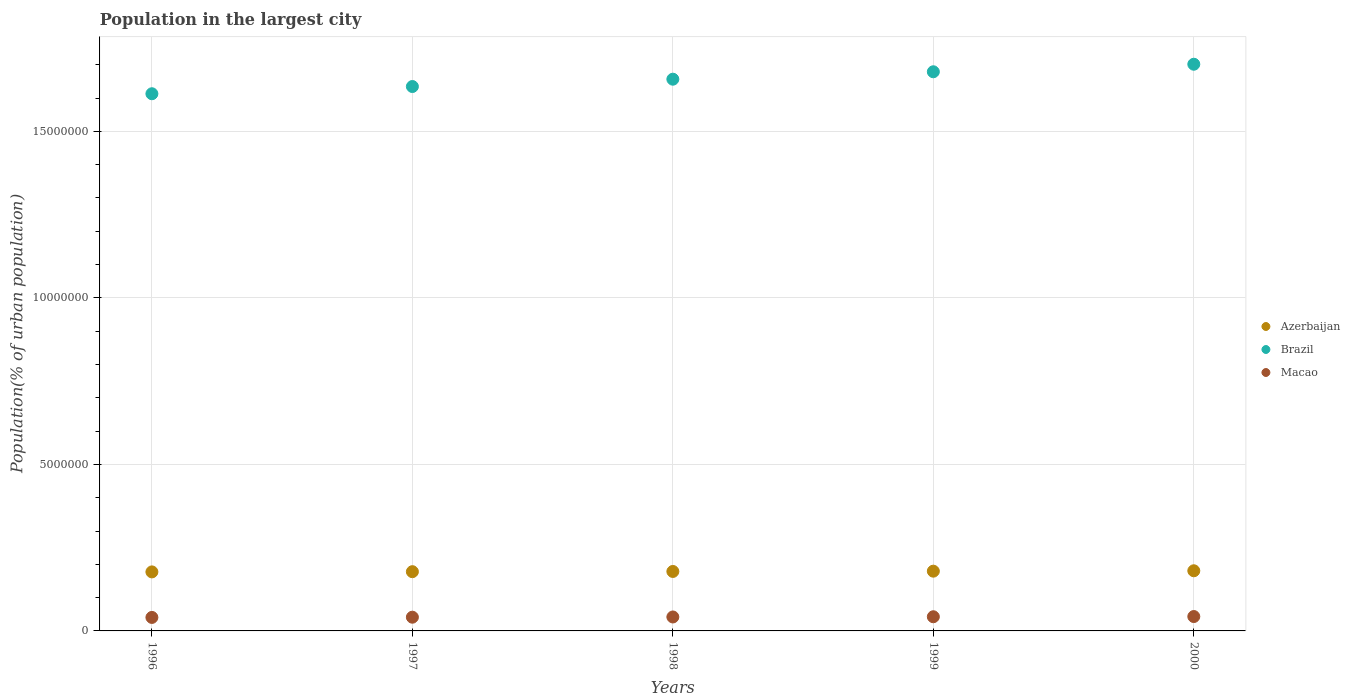How many different coloured dotlines are there?
Offer a terse response. 3. Is the number of dotlines equal to the number of legend labels?
Provide a succinct answer. Yes. What is the population in the largest city in Brazil in 1997?
Offer a very short reply. 1.63e+07. Across all years, what is the maximum population in the largest city in Brazil?
Give a very brief answer. 1.70e+07. Across all years, what is the minimum population in the largest city in Macao?
Your answer should be compact. 4.05e+05. What is the total population in the largest city in Brazil in the graph?
Ensure brevity in your answer.  8.28e+07. What is the difference between the population in the largest city in Macao in 1996 and that in 1999?
Give a very brief answer. -2.03e+04. What is the difference between the population in the largest city in Macao in 1997 and the population in the largest city in Brazil in 2000?
Make the answer very short. -1.66e+07. What is the average population in the largest city in Azerbaijan per year?
Make the answer very short. 1.79e+06. In the year 1996, what is the difference between the population in the largest city in Macao and population in the largest city in Azerbaijan?
Make the answer very short. -1.37e+06. What is the ratio of the population in the largest city in Brazil in 1998 to that in 2000?
Ensure brevity in your answer.  0.97. Is the population in the largest city in Macao in 1998 less than that in 2000?
Ensure brevity in your answer.  Yes. What is the difference between the highest and the second highest population in the largest city in Azerbaijan?
Provide a succinct answer. 1.20e+04. What is the difference between the highest and the lowest population in the largest city in Azerbaijan?
Make the answer very short. 3.39e+04. In how many years, is the population in the largest city in Macao greater than the average population in the largest city in Macao taken over all years?
Offer a terse response. 3. Is the sum of the population in the largest city in Azerbaijan in 1998 and 2000 greater than the maximum population in the largest city in Brazil across all years?
Offer a terse response. No. Does the population in the largest city in Macao monotonically increase over the years?
Your answer should be very brief. Yes. Is the population in the largest city in Azerbaijan strictly greater than the population in the largest city in Macao over the years?
Give a very brief answer. Yes. How many years are there in the graph?
Ensure brevity in your answer.  5. Are the values on the major ticks of Y-axis written in scientific E-notation?
Ensure brevity in your answer.  No. Where does the legend appear in the graph?
Ensure brevity in your answer.  Center right. What is the title of the graph?
Give a very brief answer. Population in the largest city. Does "Brazil" appear as one of the legend labels in the graph?
Offer a very short reply. Yes. What is the label or title of the X-axis?
Provide a short and direct response. Years. What is the label or title of the Y-axis?
Keep it short and to the point. Population(% of urban population). What is the Population(% of urban population) of Azerbaijan in 1996?
Ensure brevity in your answer.  1.77e+06. What is the Population(% of urban population) in Brazil in 1996?
Make the answer very short. 1.61e+07. What is the Population(% of urban population) in Macao in 1996?
Ensure brevity in your answer.  4.05e+05. What is the Population(% of urban population) of Azerbaijan in 1997?
Provide a short and direct response. 1.78e+06. What is the Population(% of urban population) of Brazil in 1997?
Provide a short and direct response. 1.63e+07. What is the Population(% of urban population) in Macao in 1997?
Provide a short and direct response. 4.12e+05. What is the Population(% of urban population) in Azerbaijan in 1998?
Offer a terse response. 1.79e+06. What is the Population(% of urban population) of Brazil in 1998?
Keep it short and to the point. 1.66e+07. What is the Population(% of urban population) of Macao in 1998?
Offer a terse response. 4.19e+05. What is the Population(% of urban population) in Azerbaijan in 1999?
Provide a short and direct response. 1.79e+06. What is the Population(% of urban population) of Brazil in 1999?
Provide a succinct answer. 1.68e+07. What is the Population(% of urban population) of Macao in 1999?
Your answer should be compact. 4.25e+05. What is the Population(% of urban population) in Azerbaijan in 2000?
Offer a very short reply. 1.81e+06. What is the Population(% of urban population) of Brazil in 2000?
Provide a short and direct response. 1.70e+07. What is the Population(% of urban population) in Macao in 2000?
Offer a very short reply. 4.32e+05. Across all years, what is the maximum Population(% of urban population) in Azerbaijan?
Your answer should be compact. 1.81e+06. Across all years, what is the maximum Population(% of urban population) in Brazil?
Your answer should be very brief. 1.70e+07. Across all years, what is the maximum Population(% of urban population) in Macao?
Make the answer very short. 4.32e+05. Across all years, what is the minimum Population(% of urban population) in Azerbaijan?
Offer a very short reply. 1.77e+06. Across all years, what is the minimum Population(% of urban population) in Brazil?
Ensure brevity in your answer.  1.61e+07. Across all years, what is the minimum Population(% of urban population) in Macao?
Make the answer very short. 4.05e+05. What is the total Population(% of urban population) in Azerbaijan in the graph?
Offer a very short reply. 8.94e+06. What is the total Population(% of urban population) in Brazil in the graph?
Provide a succinct answer. 8.28e+07. What is the total Population(% of urban population) of Macao in the graph?
Ensure brevity in your answer.  2.09e+06. What is the difference between the Population(% of urban population) in Azerbaijan in 1996 and that in 1997?
Your answer should be very brief. -6504. What is the difference between the Population(% of urban population) in Brazil in 1996 and that in 1997?
Make the answer very short. -2.17e+05. What is the difference between the Population(% of urban population) of Macao in 1996 and that in 1997?
Give a very brief answer. -6883. What is the difference between the Population(% of urban population) in Azerbaijan in 1996 and that in 1998?
Give a very brief answer. -1.30e+04. What is the difference between the Population(% of urban population) in Brazil in 1996 and that in 1998?
Ensure brevity in your answer.  -4.37e+05. What is the difference between the Population(% of urban population) of Macao in 1996 and that in 1998?
Provide a succinct answer. -1.37e+04. What is the difference between the Population(% of urban population) in Azerbaijan in 1996 and that in 1999?
Your response must be concise. -2.19e+04. What is the difference between the Population(% of urban population) in Brazil in 1996 and that in 1999?
Offer a terse response. -6.60e+05. What is the difference between the Population(% of urban population) in Macao in 1996 and that in 1999?
Offer a terse response. -2.03e+04. What is the difference between the Population(% of urban population) in Azerbaijan in 1996 and that in 2000?
Provide a succinct answer. -3.39e+04. What is the difference between the Population(% of urban population) in Brazil in 1996 and that in 2000?
Your answer should be compact. -8.86e+05. What is the difference between the Population(% of urban population) in Macao in 1996 and that in 2000?
Give a very brief answer. -2.68e+04. What is the difference between the Population(% of urban population) in Azerbaijan in 1997 and that in 1998?
Offer a terse response. -6537. What is the difference between the Population(% of urban population) in Brazil in 1997 and that in 1998?
Provide a succinct answer. -2.20e+05. What is the difference between the Population(% of urban population) in Macao in 1997 and that in 1998?
Give a very brief answer. -6779. What is the difference between the Population(% of urban population) of Azerbaijan in 1997 and that in 1999?
Keep it short and to the point. -1.54e+04. What is the difference between the Population(% of urban population) of Brazil in 1997 and that in 1999?
Your answer should be compact. -4.43e+05. What is the difference between the Population(% of urban population) of Macao in 1997 and that in 1999?
Your answer should be compact. -1.34e+04. What is the difference between the Population(% of urban population) of Azerbaijan in 1997 and that in 2000?
Your response must be concise. -2.74e+04. What is the difference between the Population(% of urban population) of Brazil in 1997 and that in 2000?
Provide a short and direct response. -6.69e+05. What is the difference between the Population(% of urban population) in Macao in 1997 and that in 2000?
Your response must be concise. -1.99e+04. What is the difference between the Population(% of urban population) of Azerbaijan in 1998 and that in 1999?
Offer a terse response. -8854. What is the difference between the Population(% of urban population) in Brazil in 1998 and that in 1999?
Offer a very short reply. -2.23e+05. What is the difference between the Population(% of urban population) in Macao in 1998 and that in 1999?
Provide a short and direct response. -6638. What is the difference between the Population(% of urban population) in Azerbaijan in 1998 and that in 2000?
Give a very brief answer. -2.09e+04. What is the difference between the Population(% of urban population) of Brazil in 1998 and that in 2000?
Give a very brief answer. -4.49e+05. What is the difference between the Population(% of urban population) in Macao in 1998 and that in 2000?
Ensure brevity in your answer.  -1.31e+04. What is the difference between the Population(% of urban population) of Azerbaijan in 1999 and that in 2000?
Ensure brevity in your answer.  -1.20e+04. What is the difference between the Population(% of urban population) in Brazil in 1999 and that in 2000?
Your answer should be very brief. -2.26e+05. What is the difference between the Population(% of urban population) of Macao in 1999 and that in 2000?
Give a very brief answer. -6459. What is the difference between the Population(% of urban population) of Azerbaijan in 1996 and the Population(% of urban population) of Brazil in 1997?
Provide a short and direct response. -1.46e+07. What is the difference between the Population(% of urban population) in Azerbaijan in 1996 and the Population(% of urban population) in Macao in 1997?
Give a very brief answer. 1.36e+06. What is the difference between the Population(% of urban population) of Brazil in 1996 and the Population(% of urban population) of Macao in 1997?
Ensure brevity in your answer.  1.57e+07. What is the difference between the Population(% of urban population) of Azerbaijan in 1996 and the Population(% of urban population) of Brazil in 1998?
Keep it short and to the point. -1.48e+07. What is the difference between the Population(% of urban population) in Azerbaijan in 1996 and the Population(% of urban population) in Macao in 1998?
Provide a succinct answer. 1.35e+06. What is the difference between the Population(% of urban population) in Brazil in 1996 and the Population(% of urban population) in Macao in 1998?
Make the answer very short. 1.57e+07. What is the difference between the Population(% of urban population) of Azerbaijan in 1996 and the Population(% of urban population) of Brazil in 1999?
Give a very brief answer. -1.50e+07. What is the difference between the Population(% of urban population) in Azerbaijan in 1996 and the Population(% of urban population) in Macao in 1999?
Offer a terse response. 1.35e+06. What is the difference between the Population(% of urban population) in Brazil in 1996 and the Population(% of urban population) in Macao in 1999?
Provide a succinct answer. 1.57e+07. What is the difference between the Population(% of urban population) in Azerbaijan in 1996 and the Population(% of urban population) in Brazil in 2000?
Keep it short and to the point. -1.52e+07. What is the difference between the Population(% of urban population) in Azerbaijan in 1996 and the Population(% of urban population) in Macao in 2000?
Ensure brevity in your answer.  1.34e+06. What is the difference between the Population(% of urban population) in Brazil in 1996 and the Population(% of urban population) in Macao in 2000?
Your answer should be compact. 1.57e+07. What is the difference between the Population(% of urban population) of Azerbaijan in 1997 and the Population(% of urban population) of Brazil in 1998?
Offer a very short reply. -1.48e+07. What is the difference between the Population(% of urban population) of Azerbaijan in 1997 and the Population(% of urban population) of Macao in 1998?
Your answer should be very brief. 1.36e+06. What is the difference between the Population(% of urban population) of Brazil in 1997 and the Population(% of urban population) of Macao in 1998?
Offer a very short reply. 1.59e+07. What is the difference between the Population(% of urban population) of Azerbaijan in 1997 and the Population(% of urban population) of Brazil in 1999?
Ensure brevity in your answer.  -1.50e+07. What is the difference between the Population(% of urban population) of Azerbaijan in 1997 and the Population(% of urban population) of Macao in 1999?
Provide a short and direct response. 1.35e+06. What is the difference between the Population(% of urban population) in Brazil in 1997 and the Population(% of urban population) in Macao in 1999?
Keep it short and to the point. 1.59e+07. What is the difference between the Population(% of urban population) in Azerbaijan in 1997 and the Population(% of urban population) in Brazil in 2000?
Make the answer very short. -1.52e+07. What is the difference between the Population(% of urban population) of Azerbaijan in 1997 and the Population(% of urban population) of Macao in 2000?
Provide a short and direct response. 1.35e+06. What is the difference between the Population(% of urban population) in Brazil in 1997 and the Population(% of urban population) in Macao in 2000?
Provide a short and direct response. 1.59e+07. What is the difference between the Population(% of urban population) of Azerbaijan in 1998 and the Population(% of urban population) of Brazil in 1999?
Provide a short and direct response. -1.50e+07. What is the difference between the Population(% of urban population) in Azerbaijan in 1998 and the Population(% of urban population) in Macao in 1999?
Offer a terse response. 1.36e+06. What is the difference between the Population(% of urban population) in Brazil in 1998 and the Population(% of urban population) in Macao in 1999?
Provide a succinct answer. 1.61e+07. What is the difference between the Population(% of urban population) of Azerbaijan in 1998 and the Population(% of urban population) of Brazil in 2000?
Provide a short and direct response. -1.52e+07. What is the difference between the Population(% of urban population) of Azerbaijan in 1998 and the Population(% of urban population) of Macao in 2000?
Give a very brief answer. 1.35e+06. What is the difference between the Population(% of urban population) in Brazil in 1998 and the Population(% of urban population) in Macao in 2000?
Give a very brief answer. 1.61e+07. What is the difference between the Population(% of urban population) in Azerbaijan in 1999 and the Population(% of urban population) in Brazil in 2000?
Make the answer very short. -1.52e+07. What is the difference between the Population(% of urban population) of Azerbaijan in 1999 and the Population(% of urban population) of Macao in 2000?
Provide a short and direct response. 1.36e+06. What is the difference between the Population(% of urban population) in Brazil in 1999 and the Population(% of urban population) in Macao in 2000?
Your answer should be compact. 1.64e+07. What is the average Population(% of urban population) of Azerbaijan per year?
Provide a short and direct response. 1.79e+06. What is the average Population(% of urban population) of Brazil per year?
Provide a short and direct response. 1.66e+07. What is the average Population(% of urban population) in Macao per year?
Keep it short and to the point. 4.19e+05. In the year 1996, what is the difference between the Population(% of urban population) in Azerbaijan and Population(% of urban population) in Brazil?
Offer a very short reply. -1.44e+07. In the year 1996, what is the difference between the Population(% of urban population) in Azerbaijan and Population(% of urban population) in Macao?
Your answer should be compact. 1.37e+06. In the year 1996, what is the difference between the Population(% of urban population) of Brazil and Population(% of urban population) of Macao?
Give a very brief answer. 1.57e+07. In the year 1997, what is the difference between the Population(% of urban population) of Azerbaijan and Population(% of urban population) of Brazil?
Provide a succinct answer. -1.46e+07. In the year 1997, what is the difference between the Population(% of urban population) in Azerbaijan and Population(% of urban population) in Macao?
Make the answer very short. 1.37e+06. In the year 1997, what is the difference between the Population(% of urban population) of Brazil and Population(% of urban population) of Macao?
Provide a short and direct response. 1.59e+07. In the year 1998, what is the difference between the Population(% of urban population) of Azerbaijan and Population(% of urban population) of Brazil?
Provide a short and direct response. -1.48e+07. In the year 1998, what is the difference between the Population(% of urban population) in Azerbaijan and Population(% of urban population) in Macao?
Make the answer very short. 1.37e+06. In the year 1998, what is the difference between the Population(% of urban population) of Brazil and Population(% of urban population) of Macao?
Your response must be concise. 1.61e+07. In the year 1999, what is the difference between the Population(% of urban population) of Azerbaijan and Population(% of urban population) of Brazil?
Your answer should be compact. -1.50e+07. In the year 1999, what is the difference between the Population(% of urban population) of Azerbaijan and Population(% of urban population) of Macao?
Your answer should be compact. 1.37e+06. In the year 1999, what is the difference between the Population(% of urban population) in Brazil and Population(% of urban population) in Macao?
Offer a terse response. 1.64e+07. In the year 2000, what is the difference between the Population(% of urban population) in Azerbaijan and Population(% of urban population) in Brazil?
Offer a terse response. -1.52e+07. In the year 2000, what is the difference between the Population(% of urban population) in Azerbaijan and Population(% of urban population) in Macao?
Make the answer very short. 1.37e+06. In the year 2000, what is the difference between the Population(% of urban population) of Brazil and Population(% of urban population) of Macao?
Provide a short and direct response. 1.66e+07. What is the ratio of the Population(% of urban population) in Azerbaijan in 1996 to that in 1997?
Your answer should be compact. 1. What is the ratio of the Population(% of urban population) in Brazil in 1996 to that in 1997?
Keep it short and to the point. 0.99. What is the ratio of the Population(% of urban population) in Macao in 1996 to that in 1997?
Your response must be concise. 0.98. What is the ratio of the Population(% of urban population) in Azerbaijan in 1996 to that in 1998?
Offer a very short reply. 0.99. What is the ratio of the Population(% of urban population) of Brazil in 1996 to that in 1998?
Your answer should be compact. 0.97. What is the ratio of the Population(% of urban population) of Macao in 1996 to that in 1998?
Your answer should be very brief. 0.97. What is the ratio of the Population(% of urban population) of Brazil in 1996 to that in 1999?
Make the answer very short. 0.96. What is the ratio of the Population(% of urban population) in Macao in 1996 to that in 1999?
Give a very brief answer. 0.95. What is the ratio of the Population(% of urban population) in Azerbaijan in 1996 to that in 2000?
Your answer should be compact. 0.98. What is the ratio of the Population(% of urban population) in Brazil in 1996 to that in 2000?
Make the answer very short. 0.95. What is the ratio of the Population(% of urban population) of Macao in 1996 to that in 2000?
Your answer should be compact. 0.94. What is the ratio of the Population(% of urban population) in Brazil in 1997 to that in 1998?
Your answer should be compact. 0.99. What is the ratio of the Population(% of urban population) of Macao in 1997 to that in 1998?
Offer a very short reply. 0.98. What is the ratio of the Population(% of urban population) of Brazil in 1997 to that in 1999?
Make the answer very short. 0.97. What is the ratio of the Population(% of urban population) of Macao in 1997 to that in 1999?
Offer a terse response. 0.97. What is the ratio of the Population(% of urban population) of Azerbaijan in 1997 to that in 2000?
Offer a terse response. 0.98. What is the ratio of the Population(% of urban population) in Brazil in 1997 to that in 2000?
Make the answer very short. 0.96. What is the ratio of the Population(% of urban population) of Macao in 1997 to that in 2000?
Your answer should be very brief. 0.95. What is the ratio of the Population(% of urban population) of Brazil in 1998 to that in 1999?
Provide a short and direct response. 0.99. What is the ratio of the Population(% of urban population) of Macao in 1998 to that in 1999?
Keep it short and to the point. 0.98. What is the ratio of the Population(% of urban population) in Azerbaijan in 1998 to that in 2000?
Your response must be concise. 0.99. What is the ratio of the Population(% of urban population) in Brazil in 1998 to that in 2000?
Ensure brevity in your answer.  0.97. What is the ratio of the Population(% of urban population) of Macao in 1998 to that in 2000?
Provide a succinct answer. 0.97. What is the ratio of the Population(% of urban population) in Brazil in 1999 to that in 2000?
Offer a terse response. 0.99. What is the ratio of the Population(% of urban population) of Macao in 1999 to that in 2000?
Ensure brevity in your answer.  0.98. What is the difference between the highest and the second highest Population(% of urban population) of Azerbaijan?
Offer a very short reply. 1.20e+04. What is the difference between the highest and the second highest Population(% of urban population) in Brazil?
Offer a terse response. 2.26e+05. What is the difference between the highest and the second highest Population(% of urban population) in Macao?
Offer a terse response. 6459. What is the difference between the highest and the lowest Population(% of urban population) in Azerbaijan?
Your answer should be very brief. 3.39e+04. What is the difference between the highest and the lowest Population(% of urban population) in Brazil?
Ensure brevity in your answer.  8.86e+05. What is the difference between the highest and the lowest Population(% of urban population) of Macao?
Your answer should be very brief. 2.68e+04. 